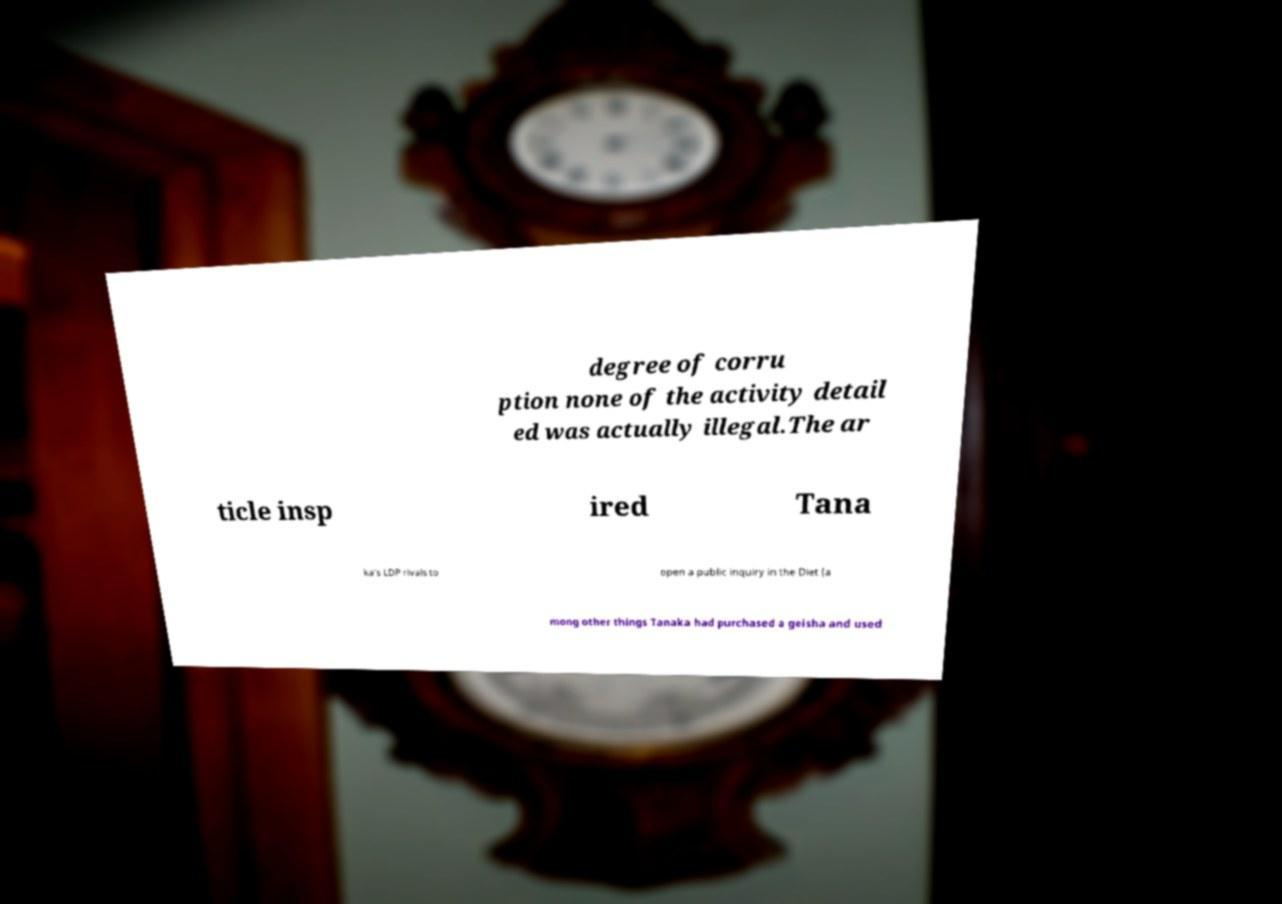For documentation purposes, I need the text within this image transcribed. Could you provide that? degree of corru ption none of the activity detail ed was actually illegal.The ar ticle insp ired Tana ka's LDP rivals to open a public inquiry in the Diet (a mong other things Tanaka had purchased a geisha and used 